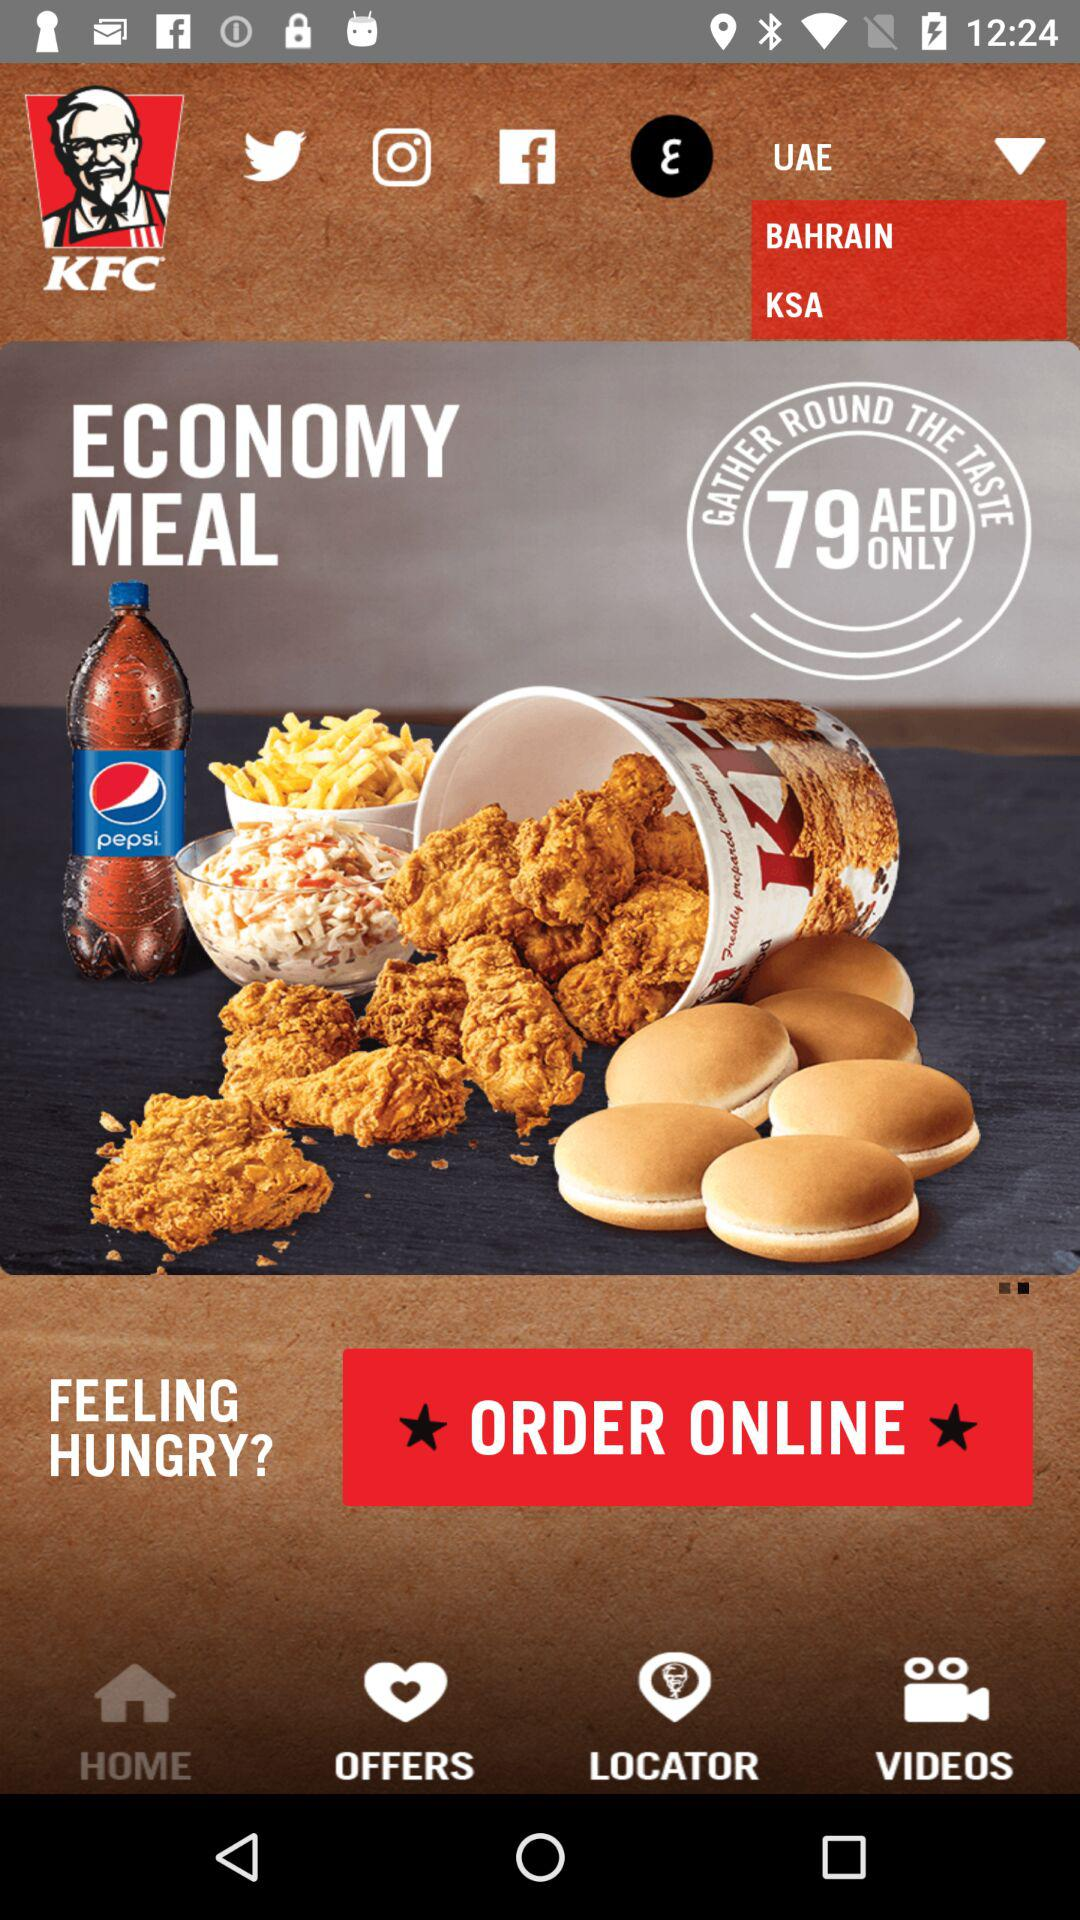What is the name of the restaurant? The name of the restaurant is "KFC". 